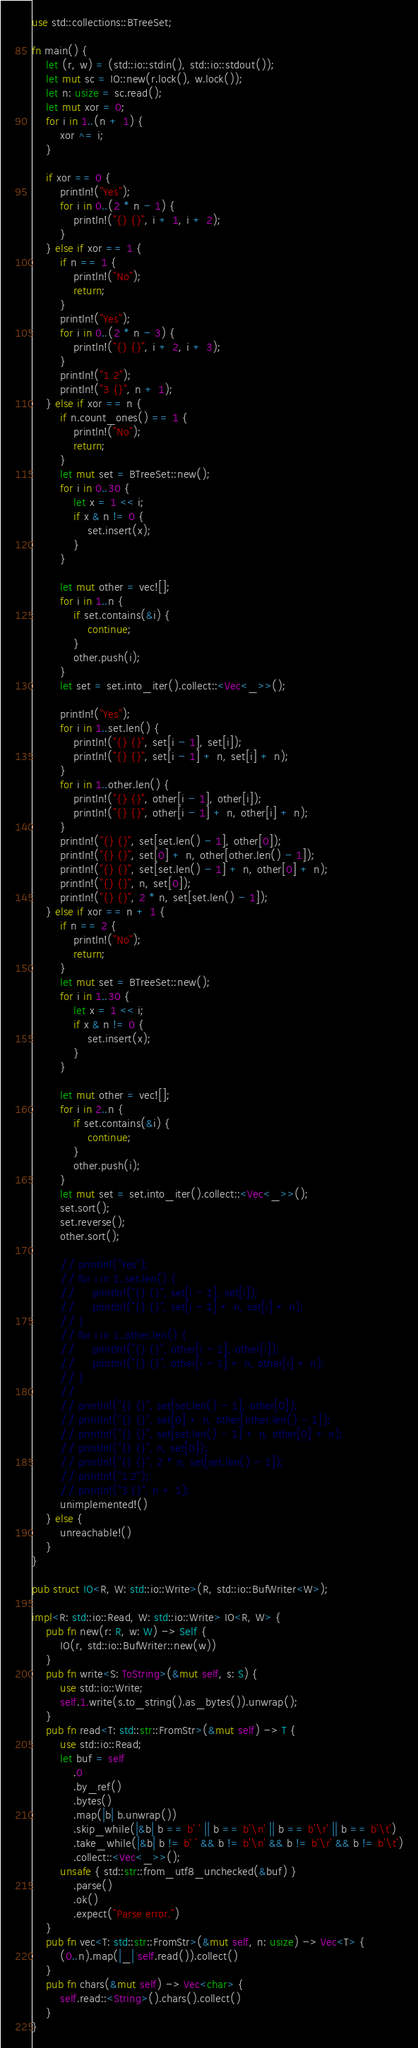<code> <loc_0><loc_0><loc_500><loc_500><_Rust_>use std::collections::BTreeSet;

fn main() {
    let (r, w) = (std::io::stdin(), std::io::stdout());
    let mut sc = IO::new(r.lock(), w.lock());
    let n: usize = sc.read();
    let mut xor = 0;
    for i in 1..(n + 1) {
        xor ^= i;
    }

    if xor == 0 {
        println!("Yes");
        for i in 0..(2 * n - 1) {
            println!("{} {}", i + 1, i + 2);
        }
    } else if xor == 1 {
        if n == 1 {
            println!("No");
            return;
        }
        println!("Yes");
        for i in 0..(2 * n - 3) {
            println!("{} {}", i + 2, i + 3);
        }
        println!("1 2");
        println!("3 {}", n + 1);
    } else if xor == n {
        if n.count_ones() == 1 {
            println!("No");
            return;
        }
        let mut set = BTreeSet::new();
        for i in 0..30 {
            let x = 1 << i;
            if x & n != 0 {
                set.insert(x);
            }
        }

        let mut other = vec![];
        for i in 1..n {
            if set.contains(&i) {
                continue;
            }
            other.push(i);
        }
        let set = set.into_iter().collect::<Vec<_>>();

        println!("Yes");
        for i in 1..set.len() {
            println!("{} {}", set[i - 1], set[i]);
            println!("{} {}", set[i - 1] + n, set[i] + n);
        }
        for i in 1..other.len() {
            println!("{} {}", other[i - 1], other[i]);
            println!("{} {}", other[i - 1] + n, other[i] + n);
        }
        println!("{} {}", set[set.len() - 1], other[0]);
        println!("{} {}", set[0] + n, other[other.len() - 1]);
        println!("{} {}", set[set.len() - 1] + n, other[0] + n);
        println!("{} {}", n, set[0]);
        println!("{} {}", 2 * n, set[set.len() - 1]);
    } else if xor == n + 1 {
        if n == 2 {
            println!("No");
            return;
        }
        let mut set = BTreeSet::new();
        for i in 1..30 {
            let x = 1 << i;
            if x & n != 0 {
                set.insert(x);
            }
        }

        let mut other = vec![];
        for i in 2..n {
            if set.contains(&i) {
                continue;
            }
            other.push(i);
        }
        let mut set = set.into_iter().collect::<Vec<_>>();
        set.sort();
        set.reverse();
        other.sort();

        // println!("Yes");
        // for i in 1..set.len() {
        //     println!("{} {}", set[i - 1], set[i]);
        //     println!("{} {}", set[i - 1] + n, set[i] + n);
        // }
        // for i in 1..other.len() {
        //     println!("{} {}", other[i - 1], other[i]);
        //     println!("{} {}", other[i - 1] + n, other[i] + n);
        // }
        //
        // println!("{} {}", set[set.len() - 1], other[0]);
        // println!("{} {}", set[0] + n, other[other.len() - 1]);
        // println!("{} {}", set[set.len() - 1] + n, other[0] + n);
        // println!("{} {}", n, set[0]);
        // println!("{} {}", 2 * n, set[set.len() - 1]);
        // println!("1 2");
        // println!("3 {}", n + 1);
        unimplemented!()
    } else {
        unreachable!()
    }
}

pub struct IO<R, W: std::io::Write>(R, std::io::BufWriter<W>);

impl<R: std::io::Read, W: std::io::Write> IO<R, W> {
    pub fn new(r: R, w: W) -> Self {
        IO(r, std::io::BufWriter::new(w))
    }
    pub fn write<S: ToString>(&mut self, s: S) {
        use std::io::Write;
        self.1.write(s.to_string().as_bytes()).unwrap();
    }
    pub fn read<T: std::str::FromStr>(&mut self) -> T {
        use std::io::Read;
        let buf = self
            .0
            .by_ref()
            .bytes()
            .map(|b| b.unwrap())
            .skip_while(|&b| b == b' ' || b == b'\n' || b == b'\r' || b == b'\t')
            .take_while(|&b| b != b' ' && b != b'\n' && b != b'\r' && b != b'\t')
            .collect::<Vec<_>>();
        unsafe { std::str::from_utf8_unchecked(&buf) }
            .parse()
            .ok()
            .expect("Parse error.")
    }
    pub fn vec<T: std::str::FromStr>(&mut self, n: usize) -> Vec<T> {
        (0..n).map(|_| self.read()).collect()
    }
    pub fn chars(&mut self) -> Vec<char> {
        self.read::<String>().chars().collect()
    }
}
</code> 